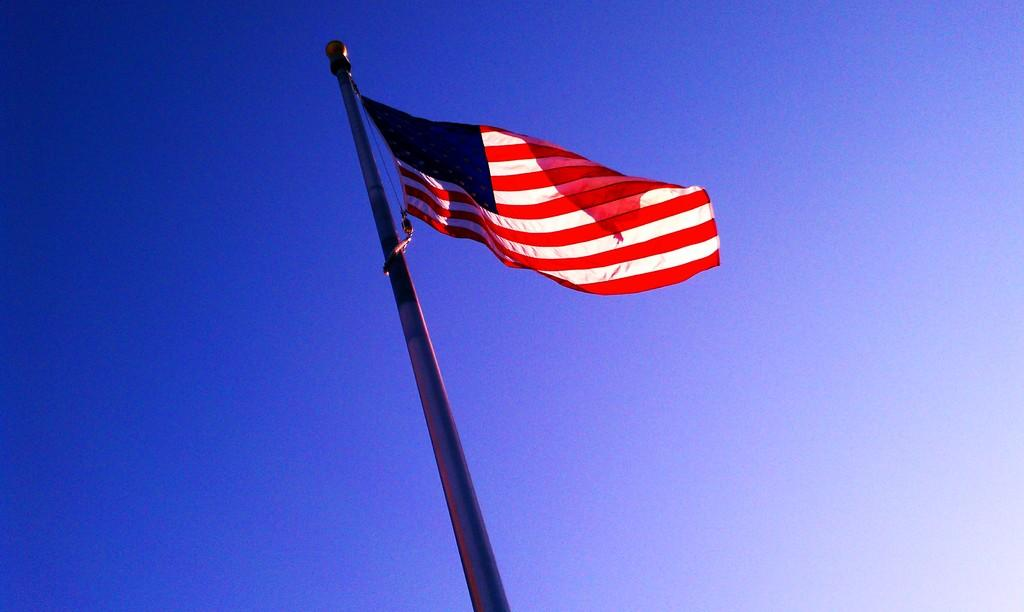What is the main object in the image? There is a flag in the image. How is the flag supported in the image? The flag is attached to a pole. What colors are present on the flag? The flag has white, red, and blue colors. What can be seen behind the flag in the image? The background of the image is the sky. What is the color of the sky in the image? The sky is blue in color. How many sisters are standing next to the flag in the image? There are no sisters present in the image; it only features a flag and a pole. What is the condition of the flag in the image? The condition of the flag cannot be determined from the image alone, as it only shows the flag and its colors. 